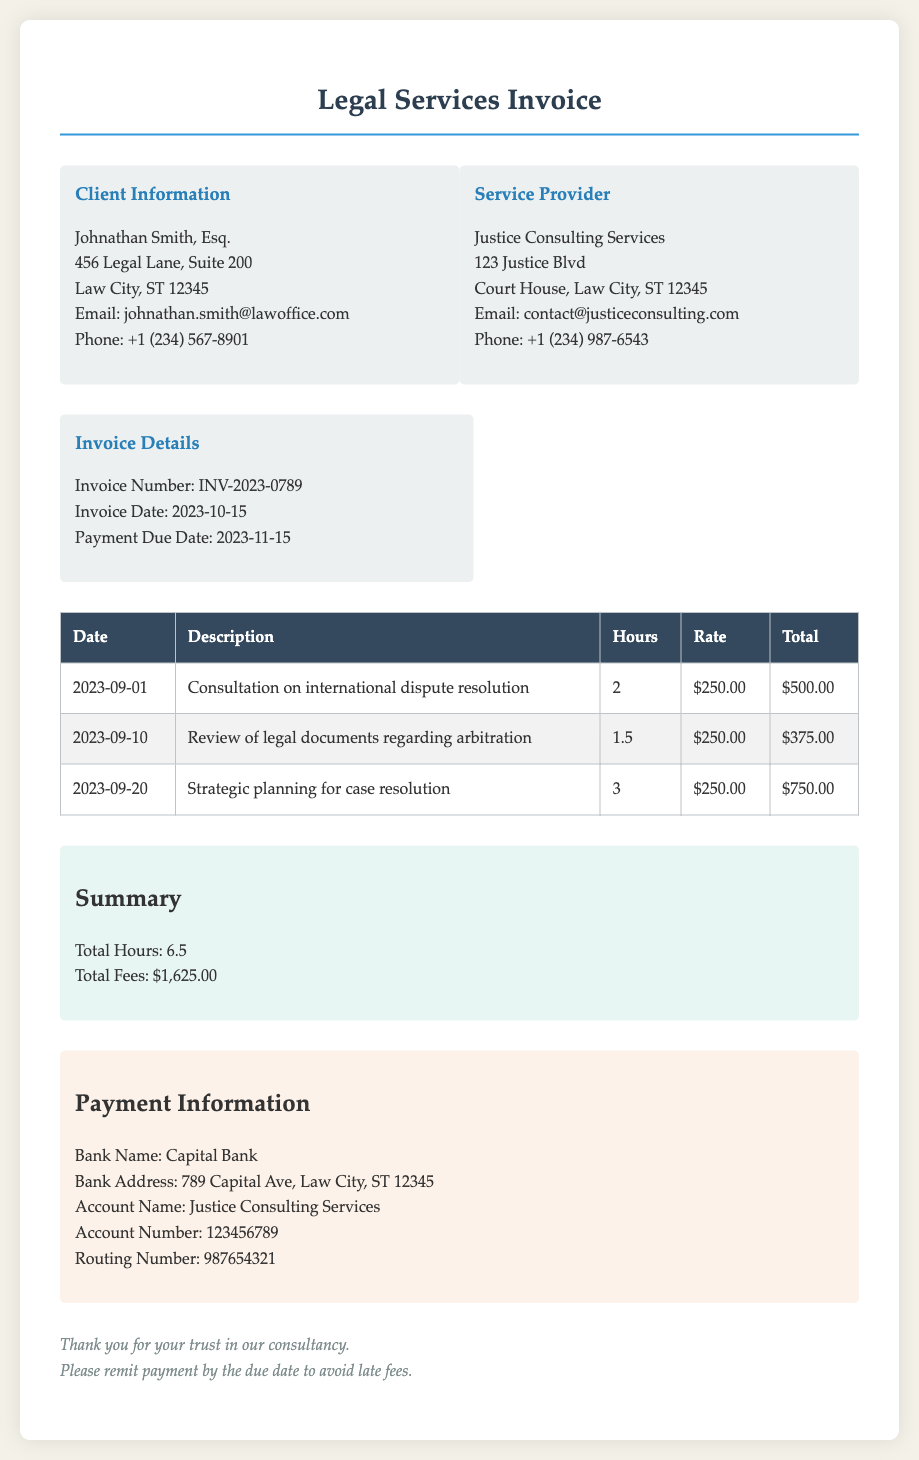What is the invoice number? The invoice number is listed in the invoice details section of the document.
Answer: INV-2023-0789 Who is the client? The client information is provided at the beginning of the invoice.
Answer: Johnathan Smith, Esq What is the total hours billed? The total hours can be found in the summary section and is the sum of the hours worked on the invoice.
Answer: 6.5 What is the rate per hour? The hourly rate is mentioned next to each line item in the invoice table.
Answer: $250.00 What is the payment due date? The payment due date is listed under the invoice details section.
Answer: 2023-11-15 How much was charged for strategic planning? The total amount charged for strategic planning is found in the invoice table under the corresponding description.
Answer: $750.00 What is the total fees incurred? The total fees incurred are summarized at the end of the invoice document.
Answer: $1,625.00 Which bank is mentioned for payment? The payment information section includes details about the bank to be used for payment.
Answer: Capital Bank What is the email address of the service provider? The service provider's email is located in the service provider section of the document.
Answer: contact@justiceconsulting.com 